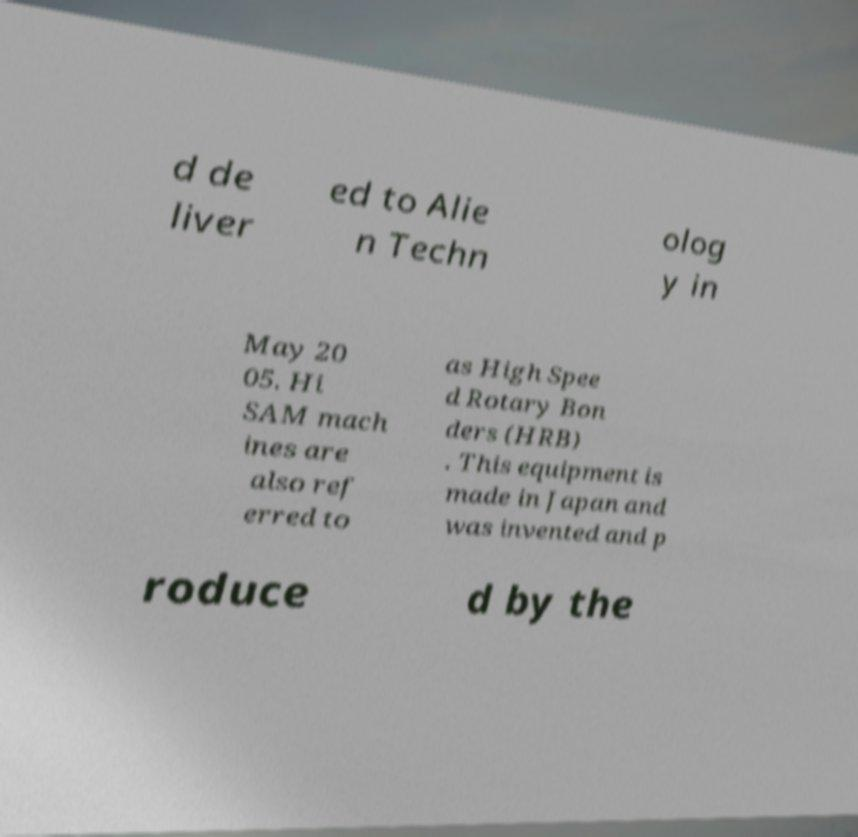I need the written content from this picture converted into text. Can you do that? d de liver ed to Alie n Techn olog y in May 20 05. Hi SAM mach ines are also ref erred to as High Spee d Rotary Bon ders (HRB) . This equipment is made in Japan and was invented and p roduce d by the 